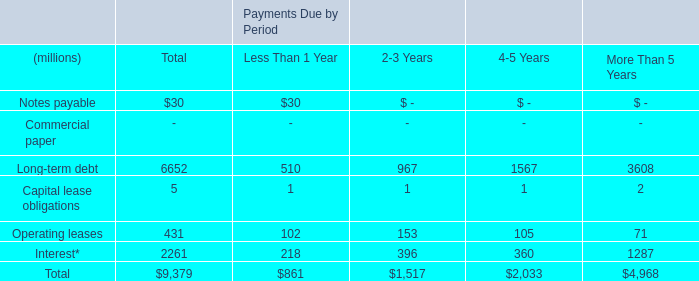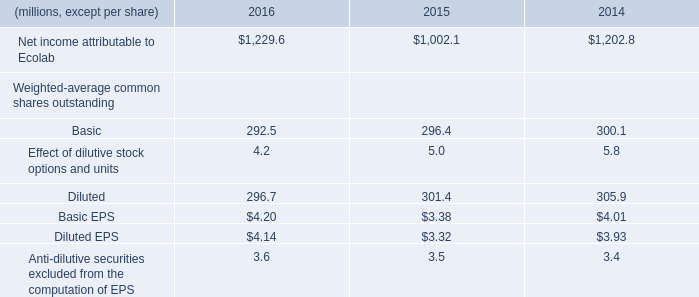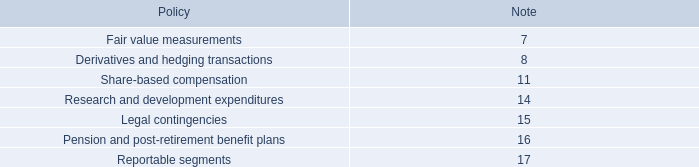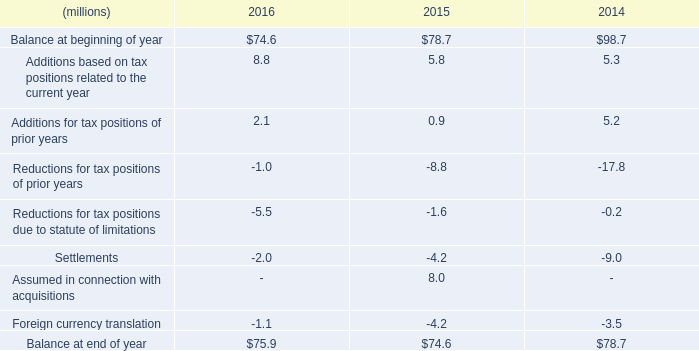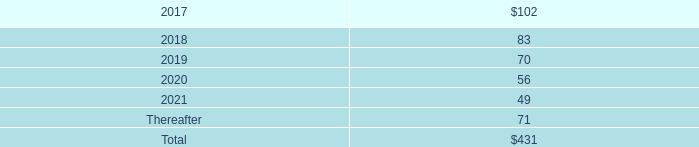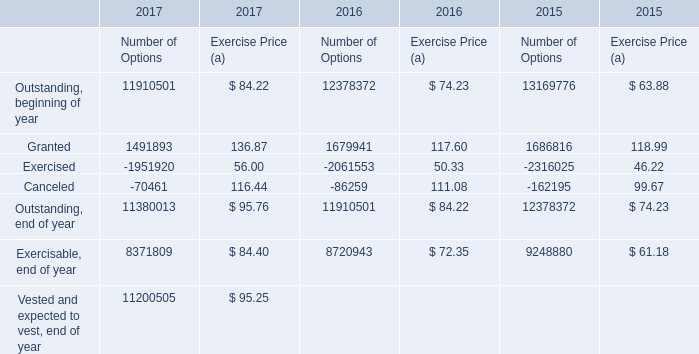If Granted for Exercise Price develops with the same increasing rate in 2017, what will it reach in 2018? 
Computations: (136.87 * (1 + ((136.87 - 117.60) / 117.60)))
Answer: 159.29759. 